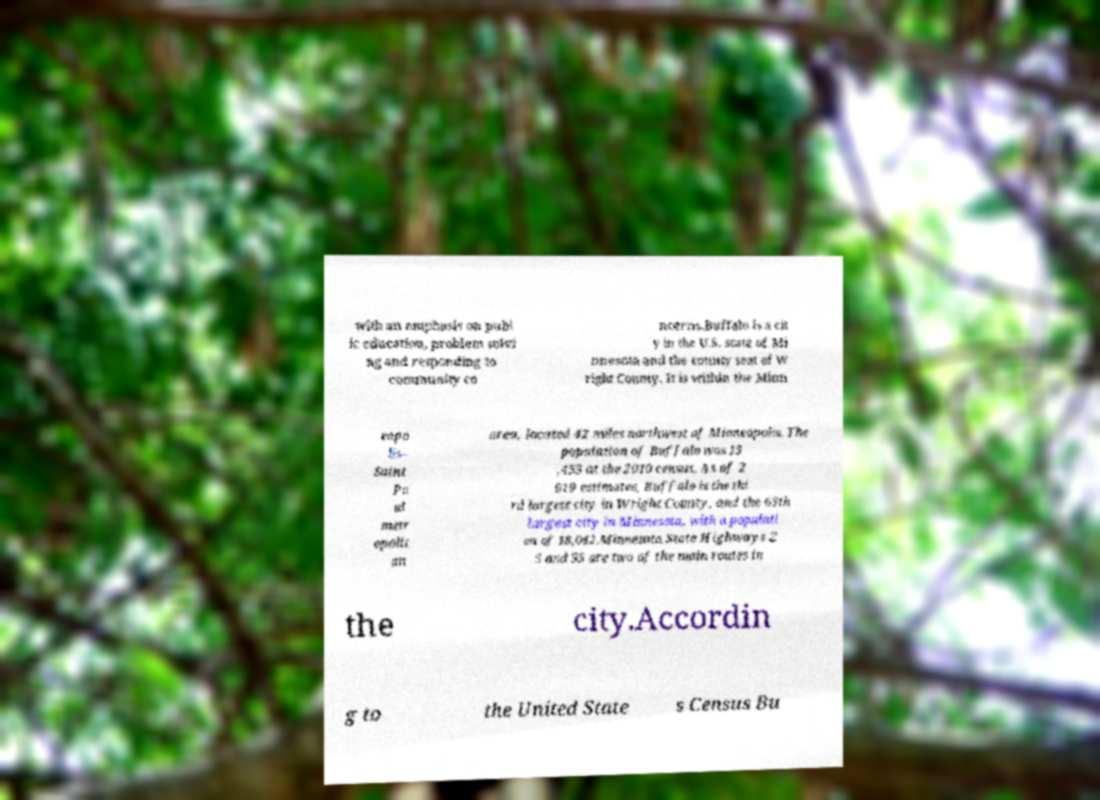What messages or text are displayed in this image? I need them in a readable, typed format. with an emphasis on publ ic education, problem solvi ng and responding to community co ncerns.Buffalo is a cit y in the U.S. state of Mi nnesota and the county seat of W right County. It is within the Minn eapo lis– Saint Pa ul metr opolit an area, located 42 miles northwest of Minneapolis. The population of Buffalo was 15 ,453 at the 2010 census. As of 2 019 estimates, Buffalo is the thi rd largest city in Wright County, and the 65th largest city in Minnesota, with a populati on of 18,042.Minnesota State Highways 2 5 and 55 are two of the main routes in the city.Accordin g to the United State s Census Bu 